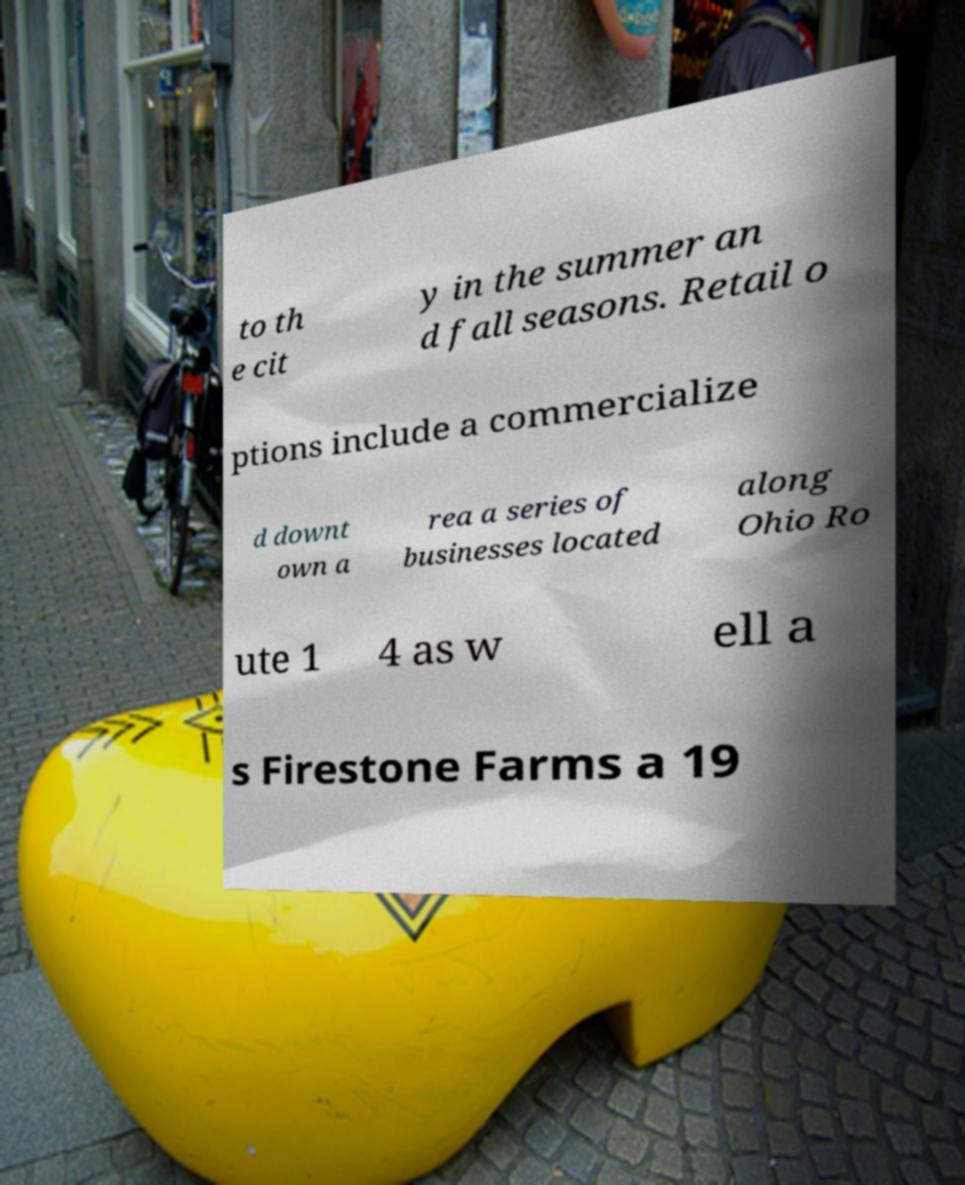Can you read and provide the text displayed in the image?This photo seems to have some interesting text. Can you extract and type it out for me? to th e cit y in the summer an d fall seasons. Retail o ptions include a commercialize d downt own a rea a series of businesses located along Ohio Ro ute 1 4 as w ell a s Firestone Farms a 19 